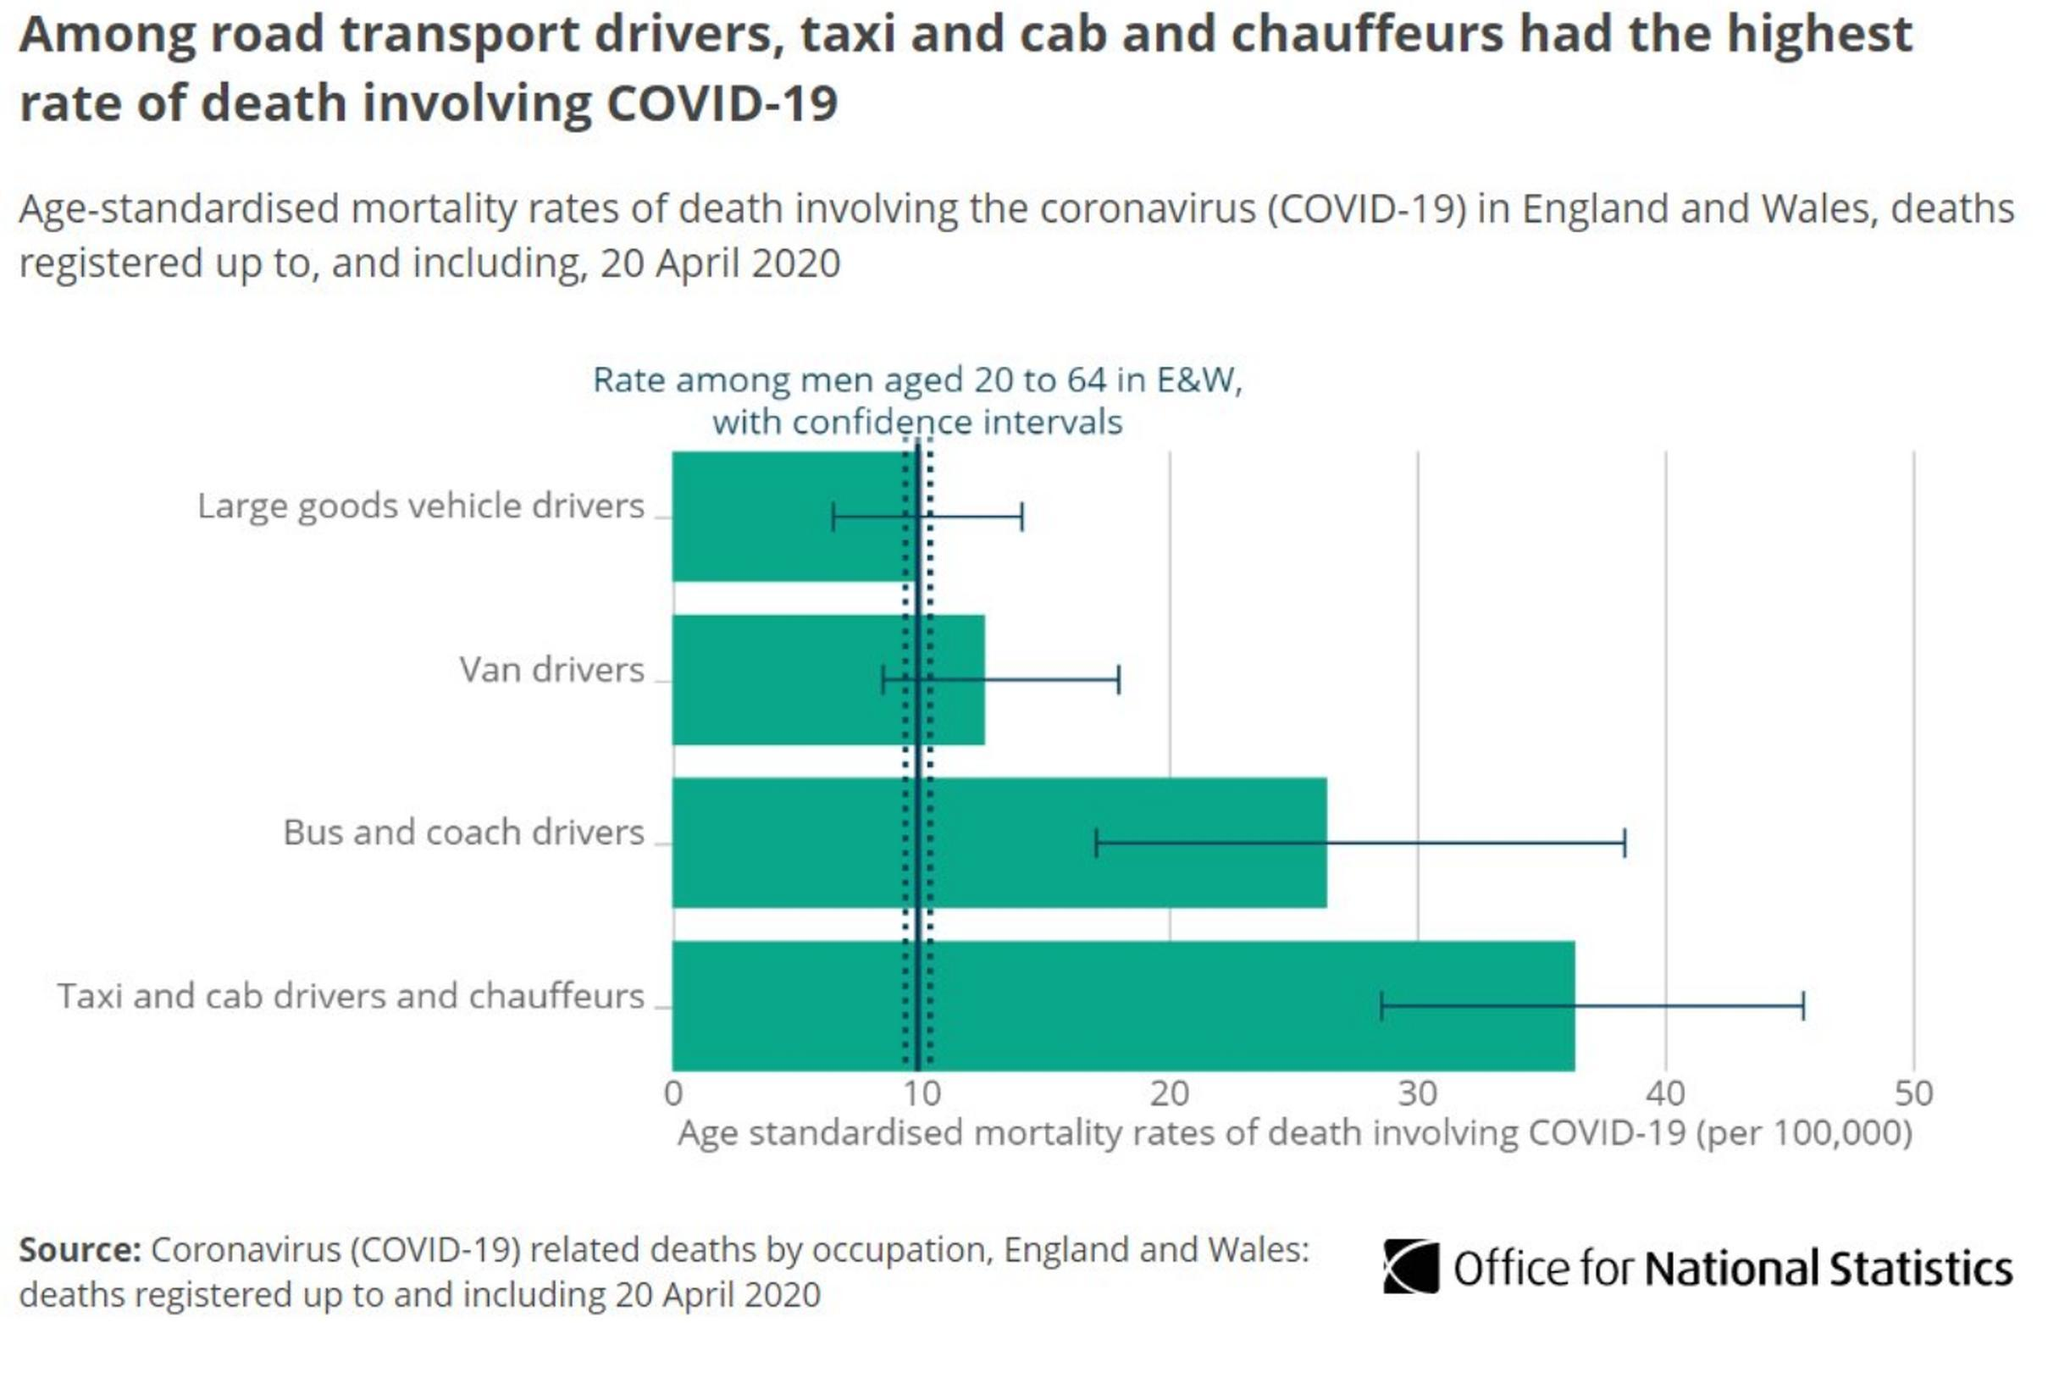Highlight a few significant elements in this photo. It is reported that among transport drivers, those who drive buses and coaches, taxis, and limousines have a death rate that exceeds 20%. Large goods vehicle drivers have been the least impacted by the COVID-19 pandemic, compared to other transport driver types. According to the data, transport drivers who specialize in van transportation and large goods vehicle transportation have a death rate that is less than 20%. 